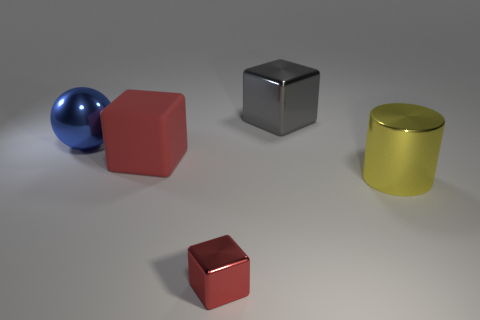Do the matte object and the small shiny thing have the same color?
Your response must be concise. Yes. What size is the metallic block that is the same color as the big rubber thing?
Make the answer very short. Small. Do the rubber cube and the cube behind the blue object have the same size?
Provide a succinct answer. Yes. What material is the thing that is left of the big cube that is in front of the cube behind the big matte thing?
Provide a short and direct response. Metal. What number of things are small red blocks or purple cubes?
Offer a terse response. 1. There is a metal cube on the left side of the large gray object; is it the same color as the large cube in front of the blue object?
Provide a short and direct response. Yes. There is a gray shiny thing that is the same size as the red matte thing; what is its shape?
Make the answer very short. Cube. What number of objects are large objects in front of the metallic ball or objects that are left of the small metal cube?
Ensure brevity in your answer.  3. Are there fewer large red matte cubes than small blue things?
Give a very brief answer. No. There is a blue object that is the same size as the gray thing; what material is it?
Offer a terse response. Metal. 